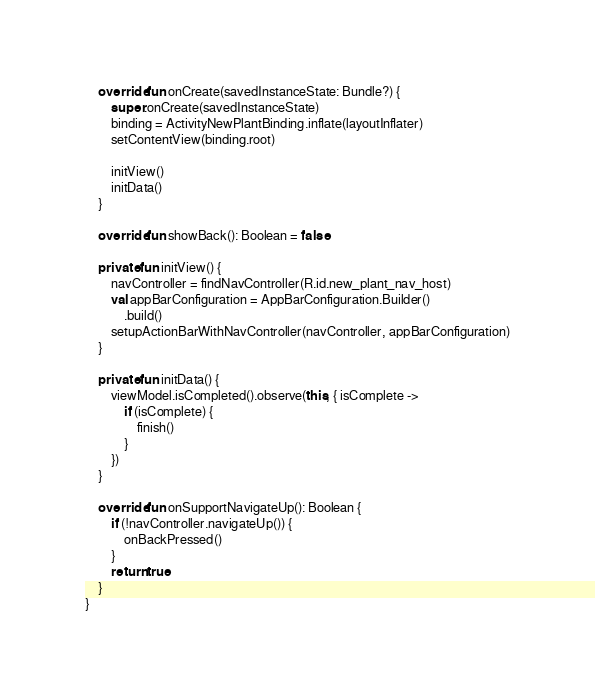<code> <loc_0><loc_0><loc_500><loc_500><_Kotlin_>    override fun onCreate(savedInstanceState: Bundle?) {
        super.onCreate(savedInstanceState)
        binding = ActivityNewPlantBinding.inflate(layoutInflater)
        setContentView(binding.root)

        initView()
        initData()
    }

    override fun showBack(): Boolean = false

    private fun initView() {
        navController = findNavController(R.id.new_plant_nav_host)
        val appBarConfiguration = AppBarConfiguration.Builder()
            .build()
        setupActionBarWithNavController(navController, appBarConfiguration)
    }

    private fun initData() {
        viewModel.isCompleted().observe(this, { isComplete ->
            if (isComplete) {
                finish()
            }
        })
    }

    override fun onSupportNavigateUp(): Boolean {
        if (!navController.navigateUp()) {
            onBackPressed()
        }
        return true
    }
}</code> 